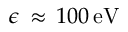<formula> <loc_0><loc_0><loc_500><loc_500>\epsilon \, \approx \, 1 0 0 \, { e V }</formula> 